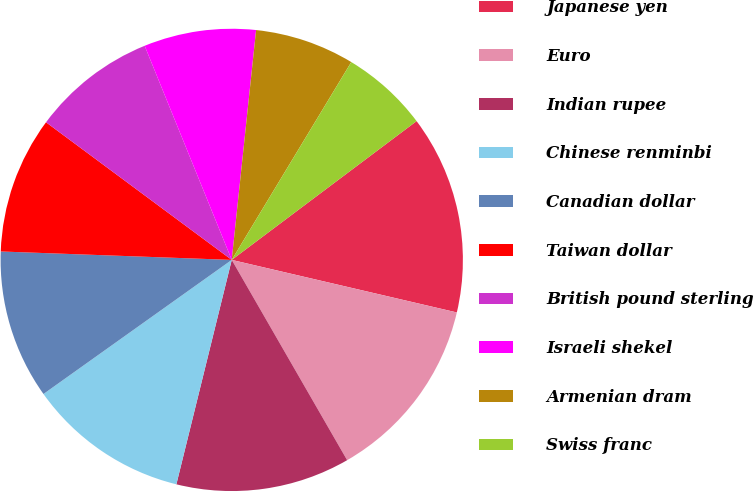Convert chart. <chart><loc_0><loc_0><loc_500><loc_500><pie_chart><fcel>Japanese yen<fcel>Euro<fcel>Indian rupee<fcel>Chinese renminbi<fcel>Canadian dollar<fcel>Taiwan dollar<fcel>British pound sterling<fcel>Israeli shekel<fcel>Armenian dram<fcel>Swiss franc<nl><fcel>13.9%<fcel>13.03%<fcel>12.17%<fcel>11.3%<fcel>10.43%<fcel>9.57%<fcel>8.7%<fcel>7.83%<fcel>6.97%<fcel>6.1%<nl></chart> 